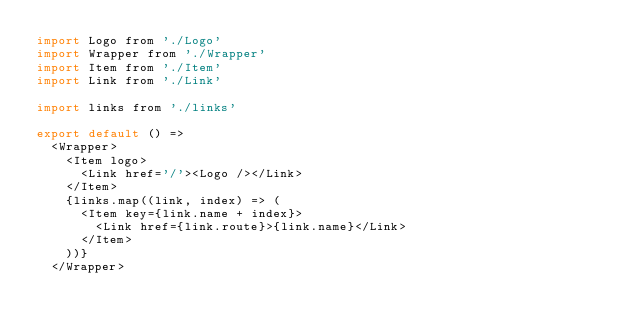<code> <loc_0><loc_0><loc_500><loc_500><_JavaScript_>import Logo from './Logo'
import Wrapper from './Wrapper'
import Item from './Item'
import Link from './Link'

import links from './links'

export default () =>
  <Wrapper>
    <Item logo>
      <Link href='/'><Logo /></Link>
    </Item>
    {links.map((link, index) => (
      <Item key={link.name + index}>
        <Link href={link.route}>{link.name}</Link>
      </Item>
    ))}
  </Wrapper>
</code> 